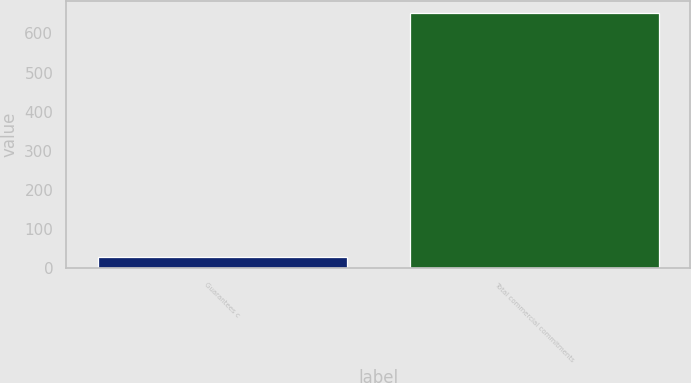<chart> <loc_0><loc_0><loc_500><loc_500><bar_chart><fcel>Guarantees c<fcel>Total commercial commitments<nl><fcel>29<fcel>651<nl></chart> 